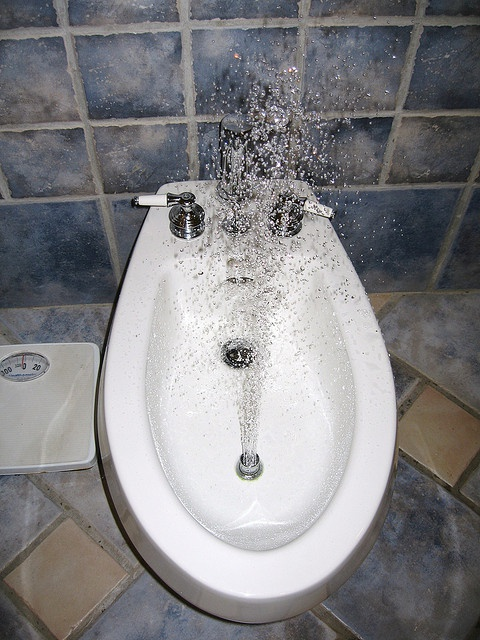Describe the objects in this image and their specific colors. I can see toilet in purple, lightgray, darkgray, gray, and black tones and sink in purple, lightgray, darkgray, and gray tones in this image. 